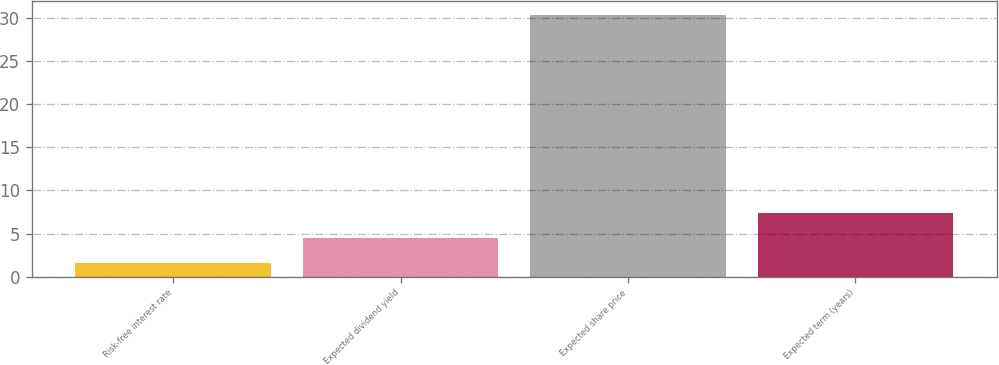<chart> <loc_0><loc_0><loc_500><loc_500><bar_chart><fcel>Risk-free interest rate<fcel>Expected dividend yield<fcel>Expected share price<fcel>Expected term (years)<nl><fcel>1.6<fcel>4.48<fcel>30.4<fcel>7.36<nl></chart> 